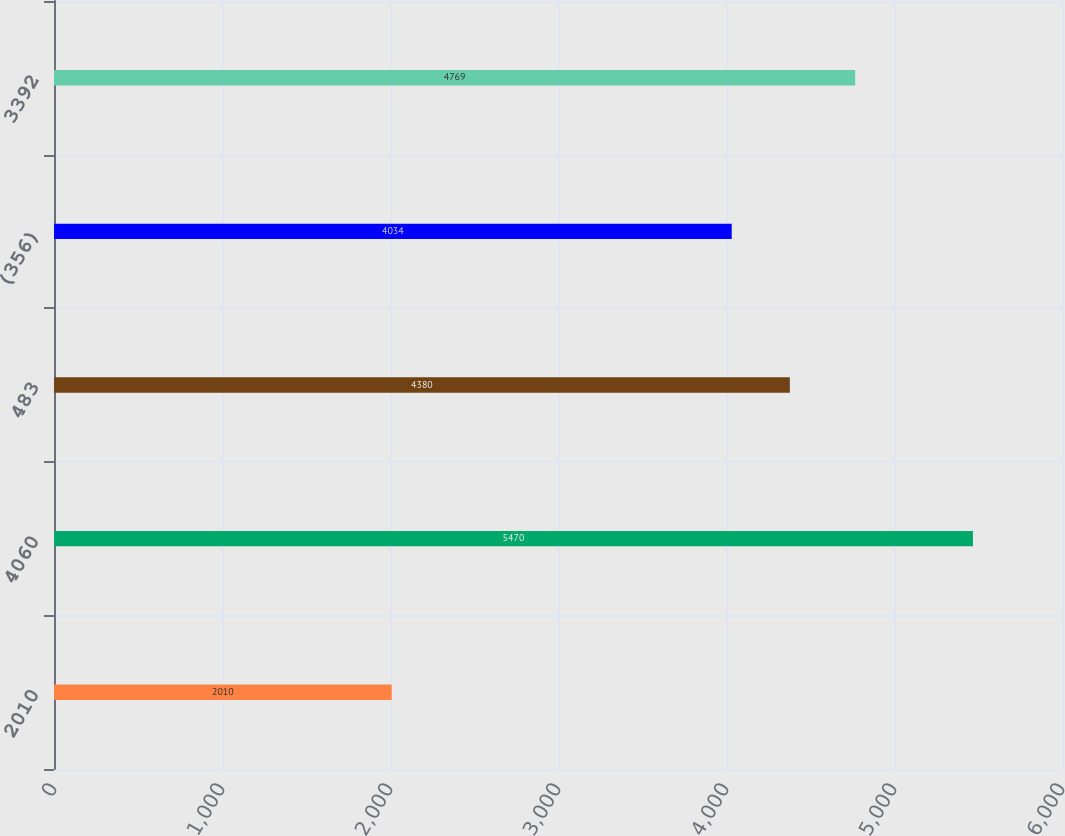Convert chart. <chart><loc_0><loc_0><loc_500><loc_500><bar_chart><fcel>2010<fcel>4060<fcel>483<fcel>(356)<fcel>3392<nl><fcel>2010<fcel>5470<fcel>4380<fcel>4034<fcel>4769<nl></chart> 